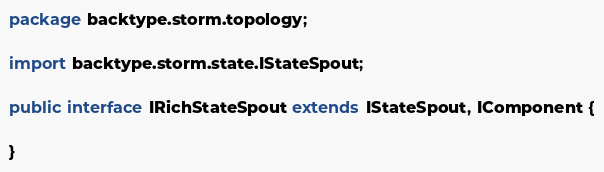<code> <loc_0><loc_0><loc_500><loc_500><_Java_>package backtype.storm.topology;

import backtype.storm.state.IStateSpout;

public interface IRichStateSpout extends IStateSpout, IComponent {

}
</code> 